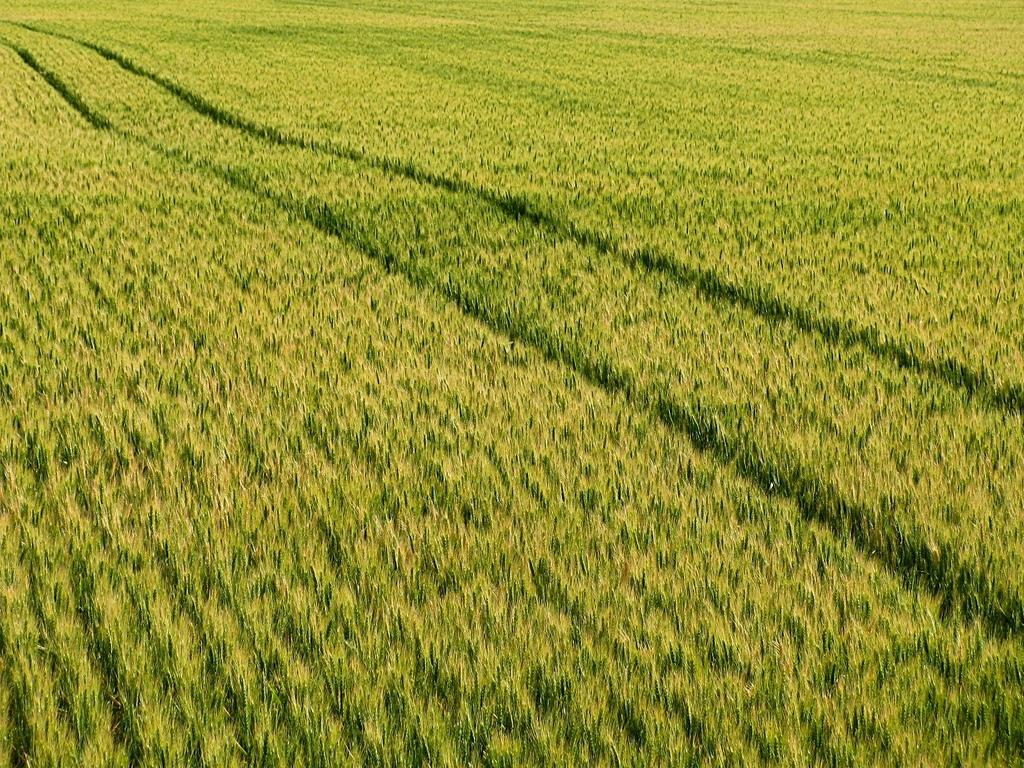Where was the image taken? The image was clicked outside the city. What is the ground covered with? The ground is covered with green grass. What is the behavior of the fifth person in the image? There is no mention of any people in the image, so it is impossible to answer a question about the behavior of a fifth person. 